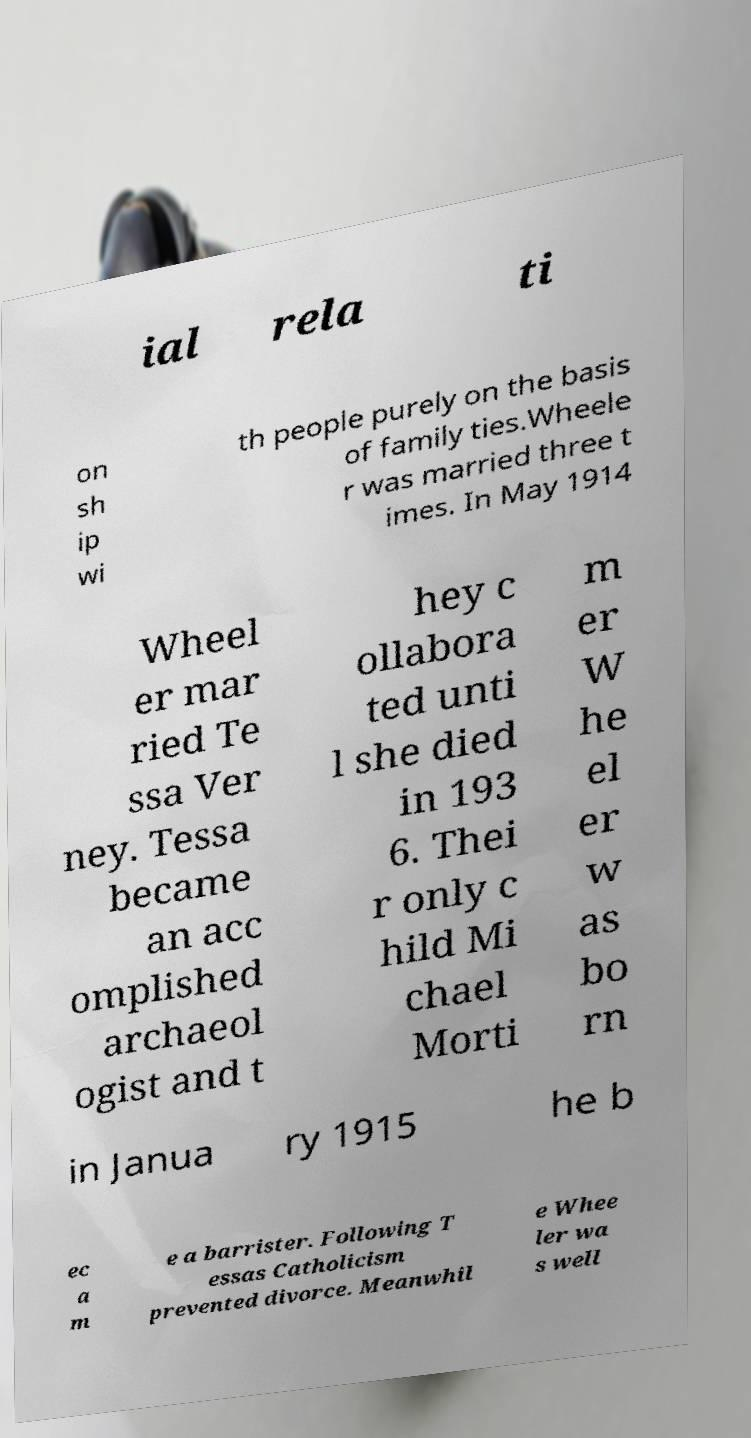Could you extract and type out the text from this image? ial rela ti on sh ip wi th people purely on the basis of family ties.Wheele r was married three t imes. In May 1914 Wheel er mar ried Te ssa Ver ney. Tessa became an acc omplished archaeol ogist and t hey c ollabora ted unti l she died in 193 6. Thei r only c hild Mi chael Morti m er W he el er w as bo rn in Janua ry 1915 he b ec a m e a barrister. Following T essas Catholicism prevented divorce. Meanwhil e Whee ler wa s well 